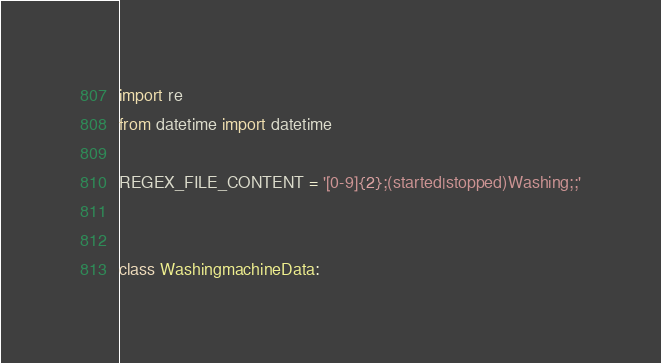Convert code to text. <code><loc_0><loc_0><loc_500><loc_500><_Python_>import re
from datetime import datetime

REGEX_FILE_CONTENT = '[0-9]{2};(started|stopped)Washing;;'


class WashingmachineData:</code> 